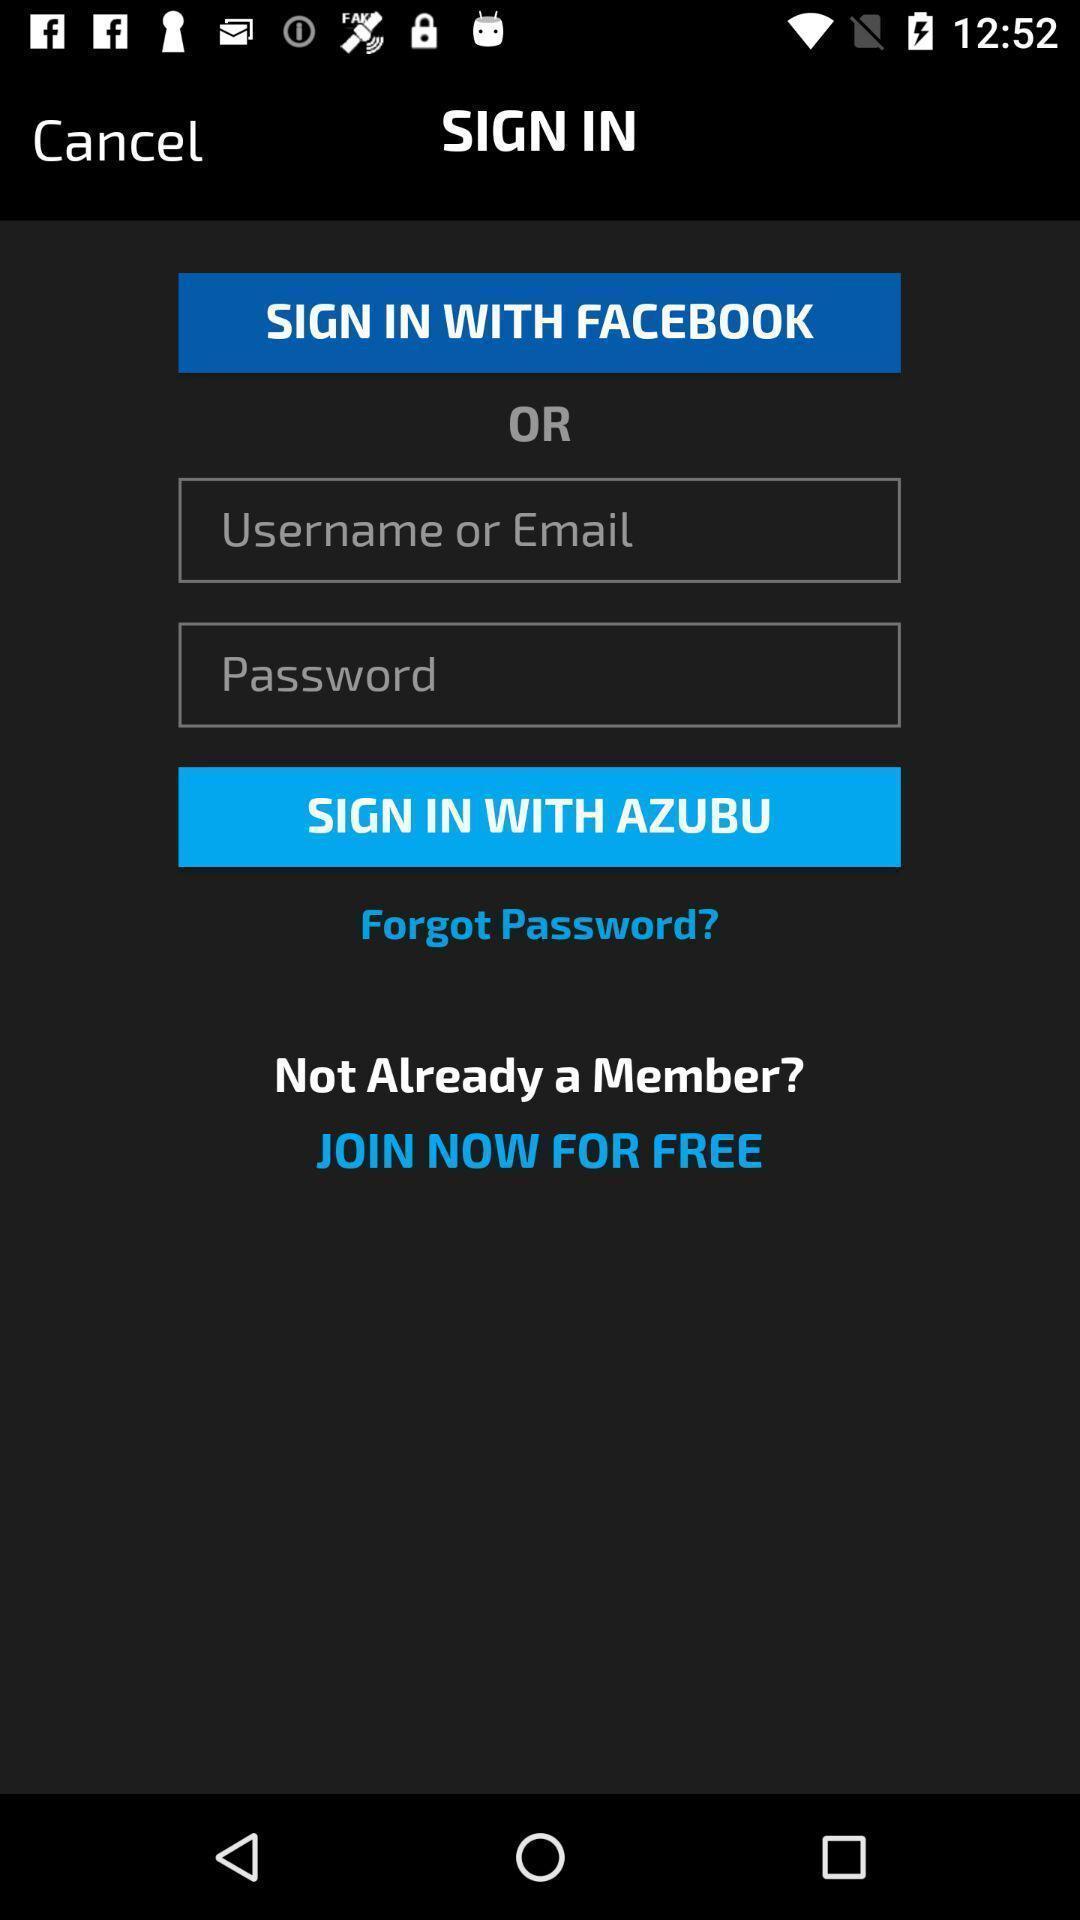Provide a detailed account of this screenshot. Sign in page with credential areas available. 